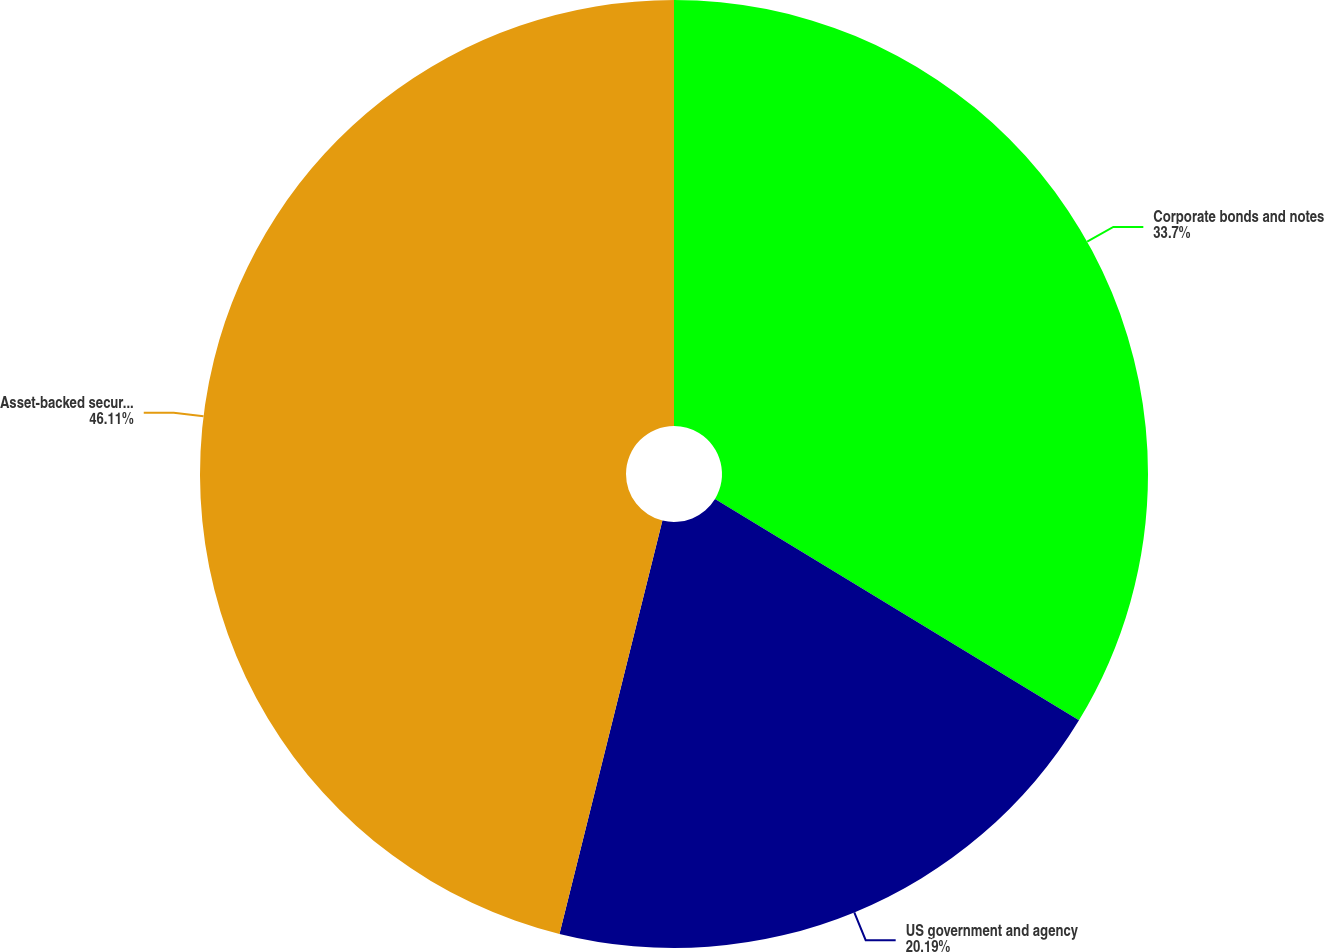Convert chart to OTSL. <chart><loc_0><loc_0><loc_500><loc_500><pie_chart><fcel>Corporate bonds and notes<fcel>US government and agency<fcel>Asset-backed securities<nl><fcel>33.7%<fcel>20.19%<fcel>46.12%<nl></chart> 